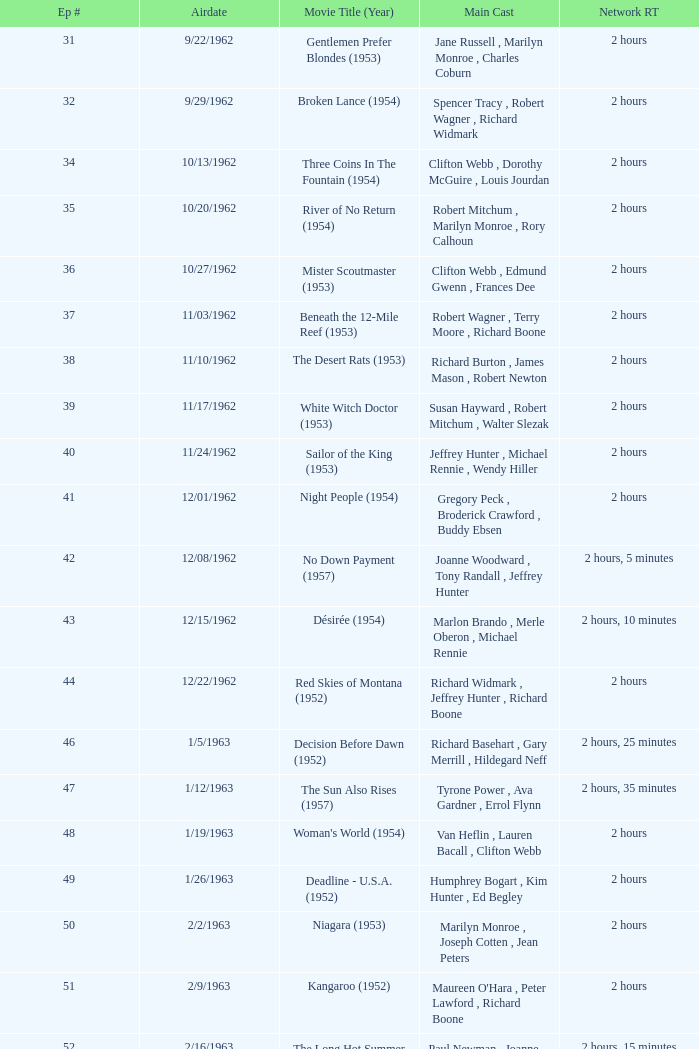Who was the cast on the 3/23/1963 episode? Dana Wynter , Mel Ferrer , Theodore Bikel. 